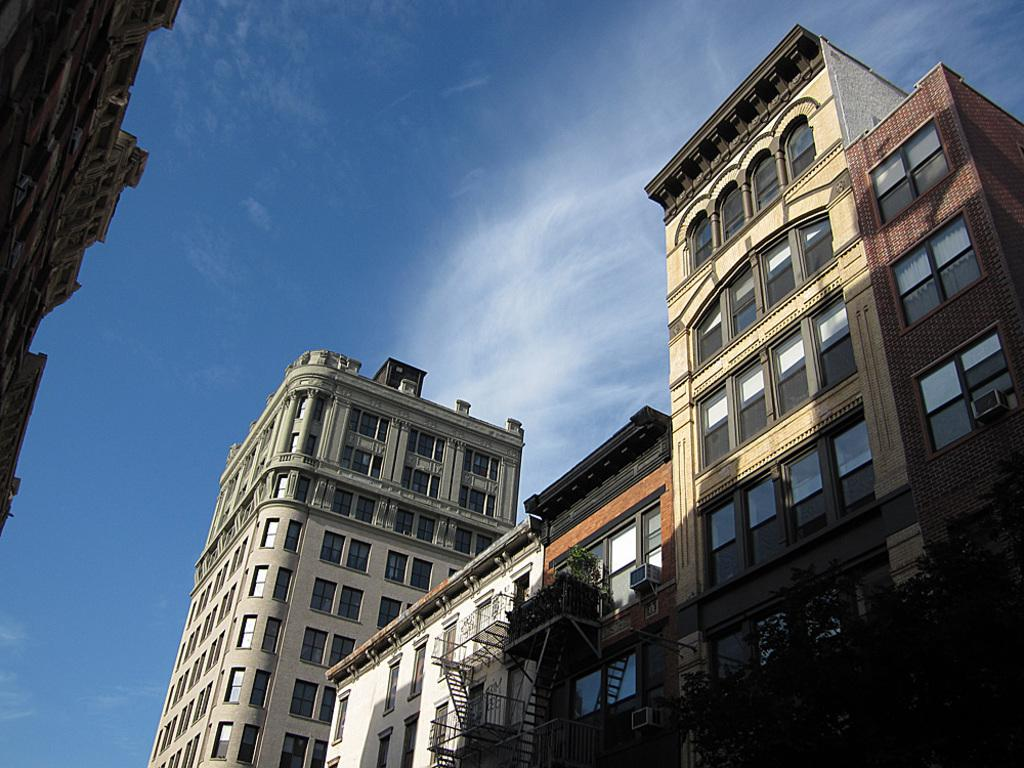What type of structures can be seen in the image? There are buildings in the image. What other elements are present in the image besides the buildings? There are plants and trees in the image. What material are the windows of the buildings made of? The buildings have glass windows. What can be seen in the background of the image? The sky is visible in the background of the image, and there are clouds in the sky. What type of quilt is draped over the trees in the image? There is no quilt present in the image; it features buildings, plants, trees, and a sky with clouds. What type of collar can be seen on the plants in the image? There are no collars present on the plants in the image; they are natural vegetation. 